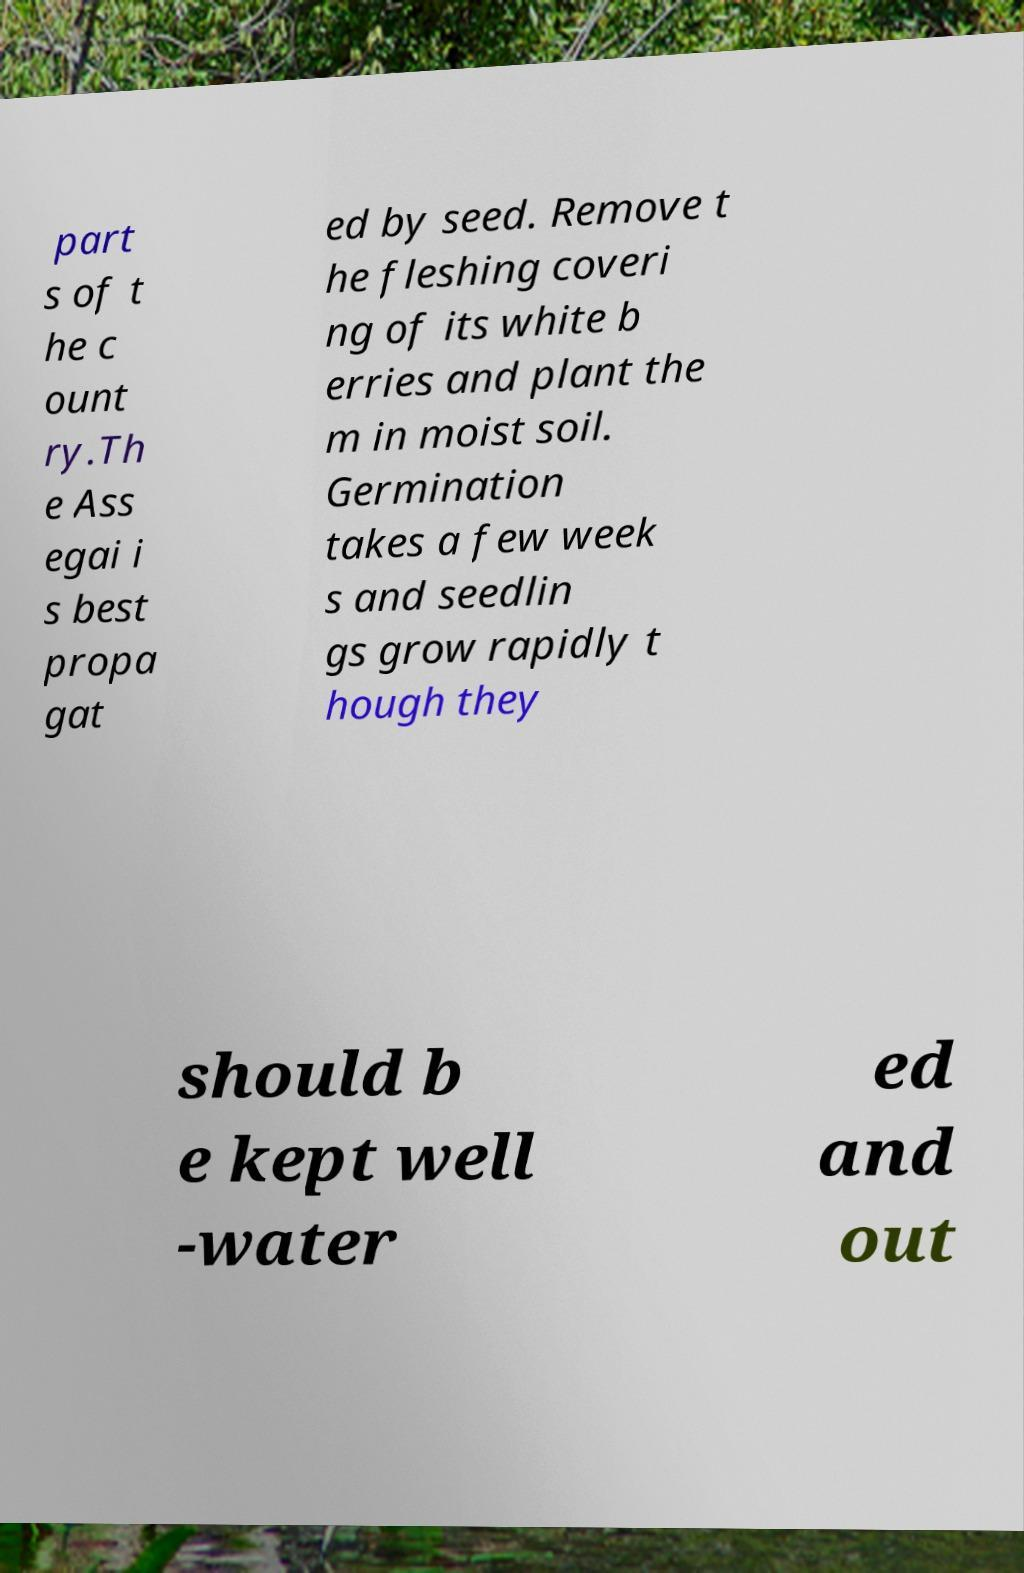I need the written content from this picture converted into text. Can you do that? part s of t he c ount ry.Th e Ass egai i s best propa gat ed by seed. Remove t he fleshing coveri ng of its white b erries and plant the m in moist soil. Germination takes a few week s and seedlin gs grow rapidly t hough they should b e kept well -water ed and out 